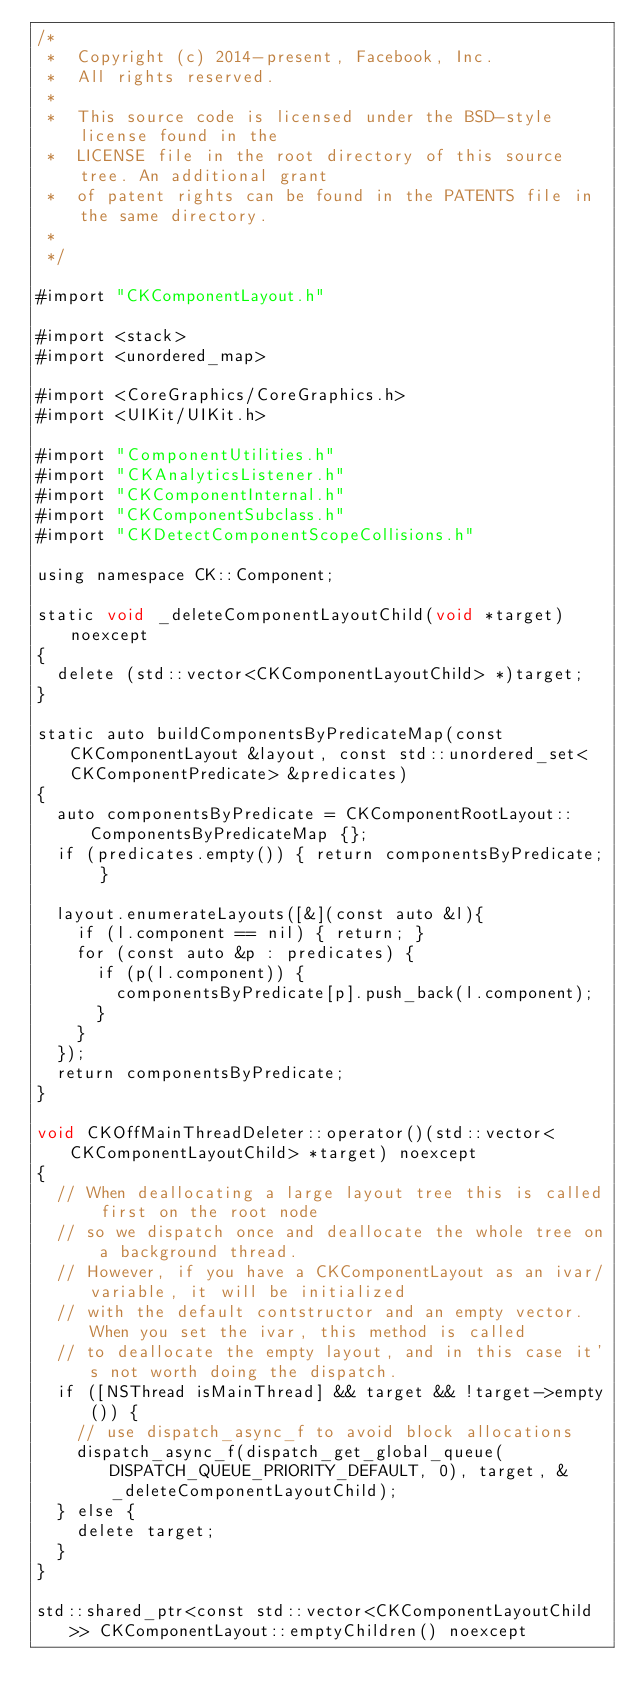Convert code to text. <code><loc_0><loc_0><loc_500><loc_500><_ObjectiveC_>/*
 *  Copyright (c) 2014-present, Facebook, Inc.
 *  All rights reserved.
 *
 *  This source code is licensed under the BSD-style license found in the
 *  LICENSE file in the root directory of this source tree. An additional grant
 *  of patent rights can be found in the PATENTS file in the same directory.
 *
 */

#import "CKComponentLayout.h"

#import <stack>
#import <unordered_map>

#import <CoreGraphics/CoreGraphics.h>
#import <UIKit/UIKit.h>

#import "ComponentUtilities.h"
#import "CKAnalyticsListener.h"
#import "CKComponentInternal.h"
#import "CKComponentSubclass.h"
#import "CKDetectComponentScopeCollisions.h"

using namespace CK::Component;

static void _deleteComponentLayoutChild(void *target) noexcept
{
  delete (std::vector<CKComponentLayoutChild> *)target;
}

static auto buildComponentsByPredicateMap(const CKComponentLayout &layout, const std::unordered_set<CKComponentPredicate> &predicates)
{
  auto componentsByPredicate = CKComponentRootLayout::ComponentsByPredicateMap {};
  if (predicates.empty()) { return componentsByPredicate; }

  layout.enumerateLayouts([&](const auto &l){
    if (l.component == nil) { return; }
    for (const auto &p : predicates) {
      if (p(l.component)) {
        componentsByPredicate[p].push_back(l.component);
      }
    }
  });
  return componentsByPredicate;
}

void CKOffMainThreadDeleter::operator()(std::vector<CKComponentLayoutChild> *target) noexcept
{
  // When deallocating a large layout tree this is called first on the root node
  // so we dispatch once and deallocate the whole tree on a background thread.
  // However, if you have a CKComponentLayout as an ivar/variable, it will be initialized
  // with the default contstructor and an empty vector. When you set the ivar, this method is called
  // to deallocate the empty layout, and in this case it's not worth doing the dispatch.
  if ([NSThread isMainThread] && target && !target->empty()) {
    // use dispatch_async_f to avoid block allocations
    dispatch_async_f(dispatch_get_global_queue(DISPATCH_QUEUE_PRIORITY_DEFAULT, 0), target, &_deleteComponentLayoutChild);
  } else {
    delete target;
  }
}

std::shared_ptr<const std::vector<CKComponentLayoutChild>> CKComponentLayout::emptyChildren() noexcept</code> 